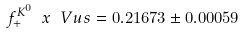Convert formula to latex. <formula><loc_0><loc_0><loc_500><loc_500>f _ { + } ^ { K ^ { 0 } } \ x \ V u s = 0 . 2 1 6 7 3 \pm 0 . 0 0 0 5 9</formula> 